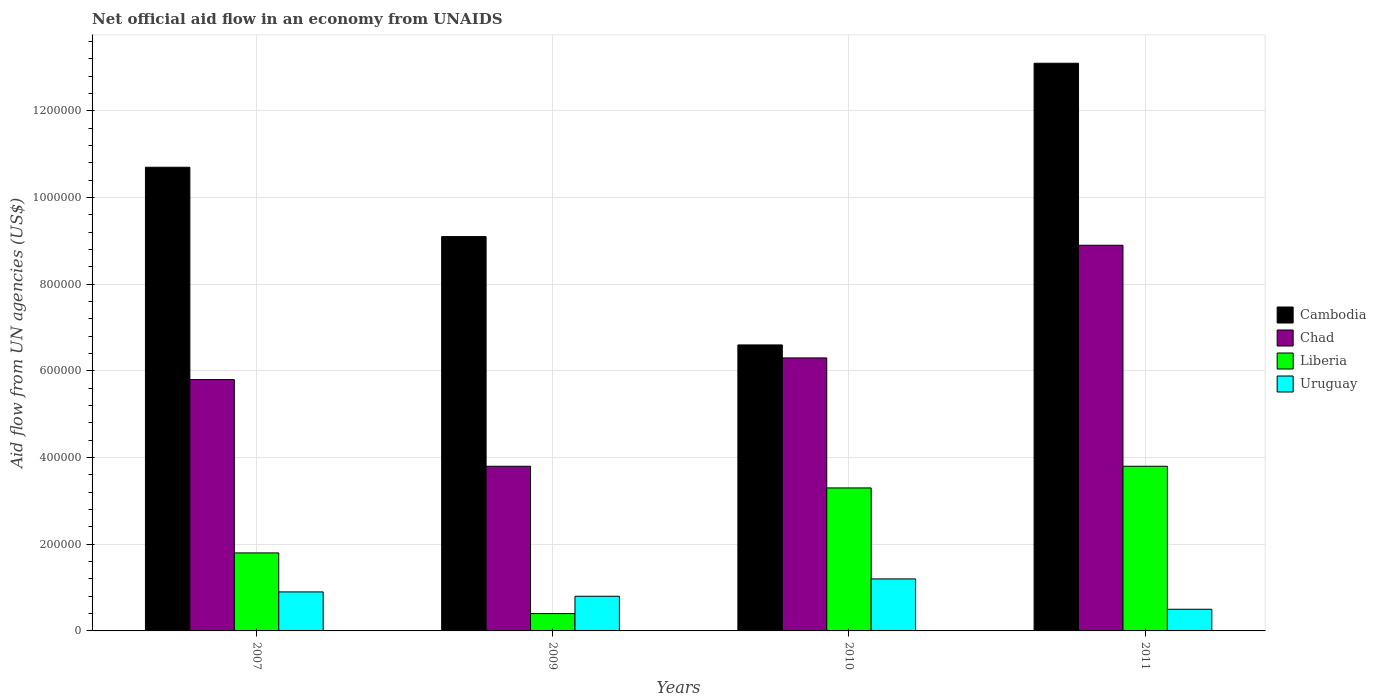How many different coloured bars are there?
Provide a succinct answer. 4. How many groups of bars are there?
Make the answer very short. 4. How many bars are there on the 1st tick from the left?
Ensure brevity in your answer.  4. How many bars are there on the 1st tick from the right?
Provide a short and direct response. 4. What is the net official aid flow in Chad in 2007?
Ensure brevity in your answer.  5.80e+05. Across all years, what is the maximum net official aid flow in Liberia?
Your response must be concise. 3.80e+05. Across all years, what is the minimum net official aid flow in Chad?
Offer a terse response. 3.80e+05. In which year was the net official aid flow in Chad maximum?
Provide a succinct answer. 2011. What is the total net official aid flow in Liberia in the graph?
Offer a terse response. 9.30e+05. What is the difference between the net official aid flow in Cambodia in 2007 and the net official aid flow in Liberia in 2009?
Your answer should be very brief. 1.03e+06. What is the average net official aid flow in Chad per year?
Ensure brevity in your answer.  6.20e+05. In the year 2009, what is the difference between the net official aid flow in Cambodia and net official aid flow in Uruguay?
Ensure brevity in your answer.  8.30e+05. In how many years, is the net official aid flow in Cambodia greater than 1120000 US$?
Make the answer very short. 1. What is the ratio of the net official aid flow in Cambodia in 2007 to that in 2011?
Give a very brief answer. 0.82. What is the difference between the highest and the second highest net official aid flow in Cambodia?
Your response must be concise. 2.40e+05. What is the difference between the highest and the lowest net official aid flow in Uruguay?
Offer a terse response. 7.00e+04. Is the sum of the net official aid flow in Cambodia in 2010 and 2011 greater than the maximum net official aid flow in Uruguay across all years?
Your answer should be very brief. Yes. Is it the case that in every year, the sum of the net official aid flow in Cambodia and net official aid flow in Chad is greater than the sum of net official aid flow in Liberia and net official aid flow in Uruguay?
Your answer should be compact. Yes. What does the 3rd bar from the left in 2007 represents?
Make the answer very short. Liberia. What does the 3rd bar from the right in 2011 represents?
Make the answer very short. Chad. How many years are there in the graph?
Make the answer very short. 4. Does the graph contain any zero values?
Keep it short and to the point. No. Does the graph contain grids?
Offer a terse response. Yes. How many legend labels are there?
Provide a succinct answer. 4. How are the legend labels stacked?
Offer a terse response. Vertical. What is the title of the graph?
Make the answer very short. Net official aid flow in an economy from UNAIDS. Does "Uganda" appear as one of the legend labels in the graph?
Provide a short and direct response. No. What is the label or title of the Y-axis?
Provide a short and direct response. Aid flow from UN agencies (US$). What is the Aid flow from UN agencies (US$) in Cambodia in 2007?
Provide a short and direct response. 1.07e+06. What is the Aid flow from UN agencies (US$) of Chad in 2007?
Offer a very short reply. 5.80e+05. What is the Aid flow from UN agencies (US$) of Liberia in 2007?
Make the answer very short. 1.80e+05. What is the Aid flow from UN agencies (US$) of Uruguay in 2007?
Keep it short and to the point. 9.00e+04. What is the Aid flow from UN agencies (US$) in Cambodia in 2009?
Ensure brevity in your answer.  9.10e+05. What is the Aid flow from UN agencies (US$) in Liberia in 2009?
Provide a short and direct response. 4.00e+04. What is the Aid flow from UN agencies (US$) of Uruguay in 2009?
Ensure brevity in your answer.  8.00e+04. What is the Aid flow from UN agencies (US$) in Chad in 2010?
Your answer should be very brief. 6.30e+05. What is the Aid flow from UN agencies (US$) of Uruguay in 2010?
Provide a short and direct response. 1.20e+05. What is the Aid flow from UN agencies (US$) of Cambodia in 2011?
Offer a terse response. 1.31e+06. What is the Aid flow from UN agencies (US$) in Chad in 2011?
Your response must be concise. 8.90e+05. What is the Aid flow from UN agencies (US$) of Liberia in 2011?
Ensure brevity in your answer.  3.80e+05. Across all years, what is the maximum Aid flow from UN agencies (US$) of Cambodia?
Your answer should be compact. 1.31e+06. Across all years, what is the maximum Aid flow from UN agencies (US$) of Chad?
Give a very brief answer. 8.90e+05. Across all years, what is the maximum Aid flow from UN agencies (US$) of Uruguay?
Make the answer very short. 1.20e+05. Across all years, what is the minimum Aid flow from UN agencies (US$) of Uruguay?
Provide a succinct answer. 5.00e+04. What is the total Aid flow from UN agencies (US$) of Cambodia in the graph?
Make the answer very short. 3.95e+06. What is the total Aid flow from UN agencies (US$) of Chad in the graph?
Offer a terse response. 2.48e+06. What is the total Aid flow from UN agencies (US$) of Liberia in the graph?
Keep it short and to the point. 9.30e+05. What is the total Aid flow from UN agencies (US$) in Uruguay in the graph?
Provide a succinct answer. 3.40e+05. What is the difference between the Aid flow from UN agencies (US$) in Uruguay in 2007 and that in 2009?
Your response must be concise. 10000. What is the difference between the Aid flow from UN agencies (US$) of Cambodia in 2007 and that in 2010?
Offer a very short reply. 4.10e+05. What is the difference between the Aid flow from UN agencies (US$) of Chad in 2007 and that in 2010?
Your answer should be very brief. -5.00e+04. What is the difference between the Aid flow from UN agencies (US$) of Chad in 2007 and that in 2011?
Keep it short and to the point. -3.10e+05. What is the difference between the Aid flow from UN agencies (US$) of Cambodia in 2009 and that in 2010?
Your answer should be very brief. 2.50e+05. What is the difference between the Aid flow from UN agencies (US$) in Chad in 2009 and that in 2010?
Make the answer very short. -2.50e+05. What is the difference between the Aid flow from UN agencies (US$) in Uruguay in 2009 and that in 2010?
Keep it short and to the point. -4.00e+04. What is the difference between the Aid flow from UN agencies (US$) of Cambodia in 2009 and that in 2011?
Your answer should be compact. -4.00e+05. What is the difference between the Aid flow from UN agencies (US$) of Chad in 2009 and that in 2011?
Make the answer very short. -5.10e+05. What is the difference between the Aid flow from UN agencies (US$) of Liberia in 2009 and that in 2011?
Your answer should be compact. -3.40e+05. What is the difference between the Aid flow from UN agencies (US$) in Uruguay in 2009 and that in 2011?
Keep it short and to the point. 3.00e+04. What is the difference between the Aid flow from UN agencies (US$) of Cambodia in 2010 and that in 2011?
Provide a succinct answer. -6.50e+05. What is the difference between the Aid flow from UN agencies (US$) in Liberia in 2010 and that in 2011?
Offer a very short reply. -5.00e+04. What is the difference between the Aid flow from UN agencies (US$) in Cambodia in 2007 and the Aid flow from UN agencies (US$) in Chad in 2009?
Keep it short and to the point. 6.90e+05. What is the difference between the Aid flow from UN agencies (US$) of Cambodia in 2007 and the Aid flow from UN agencies (US$) of Liberia in 2009?
Ensure brevity in your answer.  1.03e+06. What is the difference between the Aid flow from UN agencies (US$) in Cambodia in 2007 and the Aid flow from UN agencies (US$) in Uruguay in 2009?
Offer a very short reply. 9.90e+05. What is the difference between the Aid flow from UN agencies (US$) in Chad in 2007 and the Aid flow from UN agencies (US$) in Liberia in 2009?
Ensure brevity in your answer.  5.40e+05. What is the difference between the Aid flow from UN agencies (US$) in Liberia in 2007 and the Aid flow from UN agencies (US$) in Uruguay in 2009?
Provide a succinct answer. 1.00e+05. What is the difference between the Aid flow from UN agencies (US$) in Cambodia in 2007 and the Aid flow from UN agencies (US$) in Chad in 2010?
Give a very brief answer. 4.40e+05. What is the difference between the Aid flow from UN agencies (US$) in Cambodia in 2007 and the Aid flow from UN agencies (US$) in Liberia in 2010?
Your answer should be very brief. 7.40e+05. What is the difference between the Aid flow from UN agencies (US$) in Cambodia in 2007 and the Aid flow from UN agencies (US$) in Uruguay in 2010?
Your answer should be very brief. 9.50e+05. What is the difference between the Aid flow from UN agencies (US$) of Cambodia in 2007 and the Aid flow from UN agencies (US$) of Chad in 2011?
Provide a succinct answer. 1.80e+05. What is the difference between the Aid flow from UN agencies (US$) in Cambodia in 2007 and the Aid flow from UN agencies (US$) in Liberia in 2011?
Offer a terse response. 6.90e+05. What is the difference between the Aid flow from UN agencies (US$) in Cambodia in 2007 and the Aid flow from UN agencies (US$) in Uruguay in 2011?
Your answer should be compact. 1.02e+06. What is the difference between the Aid flow from UN agencies (US$) of Chad in 2007 and the Aid flow from UN agencies (US$) of Uruguay in 2011?
Provide a succinct answer. 5.30e+05. What is the difference between the Aid flow from UN agencies (US$) in Cambodia in 2009 and the Aid flow from UN agencies (US$) in Liberia in 2010?
Make the answer very short. 5.80e+05. What is the difference between the Aid flow from UN agencies (US$) of Cambodia in 2009 and the Aid flow from UN agencies (US$) of Uruguay in 2010?
Ensure brevity in your answer.  7.90e+05. What is the difference between the Aid flow from UN agencies (US$) in Chad in 2009 and the Aid flow from UN agencies (US$) in Liberia in 2010?
Your answer should be compact. 5.00e+04. What is the difference between the Aid flow from UN agencies (US$) in Cambodia in 2009 and the Aid flow from UN agencies (US$) in Liberia in 2011?
Make the answer very short. 5.30e+05. What is the difference between the Aid flow from UN agencies (US$) in Cambodia in 2009 and the Aid flow from UN agencies (US$) in Uruguay in 2011?
Give a very brief answer. 8.60e+05. What is the difference between the Aid flow from UN agencies (US$) in Chad in 2009 and the Aid flow from UN agencies (US$) in Liberia in 2011?
Your response must be concise. 0. What is the difference between the Aid flow from UN agencies (US$) of Chad in 2009 and the Aid flow from UN agencies (US$) of Uruguay in 2011?
Your response must be concise. 3.30e+05. What is the difference between the Aid flow from UN agencies (US$) of Liberia in 2009 and the Aid flow from UN agencies (US$) of Uruguay in 2011?
Offer a very short reply. -10000. What is the difference between the Aid flow from UN agencies (US$) of Cambodia in 2010 and the Aid flow from UN agencies (US$) of Liberia in 2011?
Provide a succinct answer. 2.80e+05. What is the difference between the Aid flow from UN agencies (US$) of Cambodia in 2010 and the Aid flow from UN agencies (US$) of Uruguay in 2011?
Offer a very short reply. 6.10e+05. What is the difference between the Aid flow from UN agencies (US$) in Chad in 2010 and the Aid flow from UN agencies (US$) in Liberia in 2011?
Give a very brief answer. 2.50e+05. What is the difference between the Aid flow from UN agencies (US$) in Chad in 2010 and the Aid flow from UN agencies (US$) in Uruguay in 2011?
Your response must be concise. 5.80e+05. What is the average Aid flow from UN agencies (US$) of Cambodia per year?
Offer a terse response. 9.88e+05. What is the average Aid flow from UN agencies (US$) of Chad per year?
Your answer should be very brief. 6.20e+05. What is the average Aid flow from UN agencies (US$) in Liberia per year?
Provide a short and direct response. 2.32e+05. What is the average Aid flow from UN agencies (US$) of Uruguay per year?
Offer a very short reply. 8.50e+04. In the year 2007, what is the difference between the Aid flow from UN agencies (US$) in Cambodia and Aid flow from UN agencies (US$) in Liberia?
Give a very brief answer. 8.90e+05. In the year 2007, what is the difference between the Aid flow from UN agencies (US$) in Cambodia and Aid flow from UN agencies (US$) in Uruguay?
Offer a very short reply. 9.80e+05. In the year 2007, what is the difference between the Aid flow from UN agencies (US$) in Chad and Aid flow from UN agencies (US$) in Uruguay?
Your answer should be compact. 4.90e+05. In the year 2009, what is the difference between the Aid flow from UN agencies (US$) in Cambodia and Aid flow from UN agencies (US$) in Chad?
Offer a terse response. 5.30e+05. In the year 2009, what is the difference between the Aid flow from UN agencies (US$) in Cambodia and Aid flow from UN agencies (US$) in Liberia?
Offer a terse response. 8.70e+05. In the year 2009, what is the difference between the Aid flow from UN agencies (US$) in Cambodia and Aid flow from UN agencies (US$) in Uruguay?
Offer a very short reply. 8.30e+05. In the year 2009, what is the difference between the Aid flow from UN agencies (US$) of Liberia and Aid flow from UN agencies (US$) of Uruguay?
Your answer should be very brief. -4.00e+04. In the year 2010, what is the difference between the Aid flow from UN agencies (US$) of Cambodia and Aid flow from UN agencies (US$) of Liberia?
Your answer should be very brief. 3.30e+05. In the year 2010, what is the difference between the Aid flow from UN agencies (US$) of Cambodia and Aid flow from UN agencies (US$) of Uruguay?
Provide a short and direct response. 5.40e+05. In the year 2010, what is the difference between the Aid flow from UN agencies (US$) of Chad and Aid flow from UN agencies (US$) of Liberia?
Ensure brevity in your answer.  3.00e+05. In the year 2010, what is the difference between the Aid flow from UN agencies (US$) in Chad and Aid flow from UN agencies (US$) in Uruguay?
Ensure brevity in your answer.  5.10e+05. In the year 2010, what is the difference between the Aid flow from UN agencies (US$) of Liberia and Aid flow from UN agencies (US$) of Uruguay?
Ensure brevity in your answer.  2.10e+05. In the year 2011, what is the difference between the Aid flow from UN agencies (US$) of Cambodia and Aid flow from UN agencies (US$) of Chad?
Your answer should be very brief. 4.20e+05. In the year 2011, what is the difference between the Aid flow from UN agencies (US$) of Cambodia and Aid flow from UN agencies (US$) of Liberia?
Provide a short and direct response. 9.30e+05. In the year 2011, what is the difference between the Aid flow from UN agencies (US$) in Cambodia and Aid flow from UN agencies (US$) in Uruguay?
Make the answer very short. 1.26e+06. In the year 2011, what is the difference between the Aid flow from UN agencies (US$) in Chad and Aid flow from UN agencies (US$) in Liberia?
Offer a terse response. 5.10e+05. In the year 2011, what is the difference between the Aid flow from UN agencies (US$) in Chad and Aid flow from UN agencies (US$) in Uruguay?
Your response must be concise. 8.40e+05. In the year 2011, what is the difference between the Aid flow from UN agencies (US$) of Liberia and Aid flow from UN agencies (US$) of Uruguay?
Ensure brevity in your answer.  3.30e+05. What is the ratio of the Aid flow from UN agencies (US$) in Cambodia in 2007 to that in 2009?
Your answer should be compact. 1.18. What is the ratio of the Aid flow from UN agencies (US$) in Chad in 2007 to that in 2009?
Keep it short and to the point. 1.53. What is the ratio of the Aid flow from UN agencies (US$) of Uruguay in 2007 to that in 2009?
Keep it short and to the point. 1.12. What is the ratio of the Aid flow from UN agencies (US$) in Cambodia in 2007 to that in 2010?
Offer a terse response. 1.62. What is the ratio of the Aid flow from UN agencies (US$) of Chad in 2007 to that in 2010?
Offer a terse response. 0.92. What is the ratio of the Aid flow from UN agencies (US$) in Liberia in 2007 to that in 2010?
Provide a short and direct response. 0.55. What is the ratio of the Aid flow from UN agencies (US$) in Cambodia in 2007 to that in 2011?
Provide a short and direct response. 0.82. What is the ratio of the Aid flow from UN agencies (US$) in Chad in 2007 to that in 2011?
Provide a short and direct response. 0.65. What is the ratio of the Aid flow from UN agencies (US$) in Liberia in 2007 to that in 2011?
Your answer should be compact. 0.47. What is the ratio of the Aid flow from UN agencies (US$) in Cambodia in 2009 to that in 2010?
Ensure brevity in your answer.  1.38. What is the ratio of the Aid flow from UN agencies (US$) of Chad in 2009 to that in 2010?
Make the answer very short. 0.6. What is the ratio of the Aid flow from UN agencies (US$) in Liberia in 2009 to that in 2010?
Provide a short and direct response. 0.12. What is the ratio of the Aid flow from UN agencies (US$) in Uruguay in 2009 to that in 2010?
Offer a very short reply. 0.67. What is the ratio of the Aid flow from UN agencies (US$) in Cambodia in 2009 to that in 2011?
Ensure brevity in your answer.  0.69. What is the ratio of the Aid flow from UN agencies (US$) of Chad in 2009 to that in 2011?
Provide a short and direct response. 0.43. What is the ratio of the Aid flow from UN agencies (US$) in Liberia in 2009 to that in 2011?
Provide a short and direct response. 0.11. What is the ratio of the Aid flow from UN agencies (US$) of Cambodia in 2010 to that in 2011?
Your answer should be compact. 0.5. What is the ratio of the Aid flow from UN agencies (US$) of Chad in 2010 to that in 2011?
Ensure brevity in your answer.  0.71. What is the ratio of the Aid flow from UN agencies (US$) of Liberia in 2010 to that in 2011?
Ensure brevity in your answer.  0.87. What is the ratio of the Aid flow from UN agencies (US$) of Uruguay in 2010 to that in 2011?
Provide a short and direct response. 2.4. What is the difference between the highest and the second highest Aid flow from UN agencies (US$) in Liberia?
Make the answer very short. 5.00e+04. What is the difference between the highest and the second highest Aid flow from UN agencies (US$) of Uruguay?
Keep it short and to the point. 3.00e+04. What is the difference between the highest and the lowest Aid flow from UN agencies (US$) of Cambodia?
Make the answer very short. 6.50e+05. What is the difference between the highest and the lowest Aid flow from UN agencies (US$) in Chad?
Keep it short and to the point. 5.10e+05. What is the difference between the highest and the lowest Aid flow from UN agencies (US$) of Liberia?
Keep it short and to the point. 3.40e+05. 